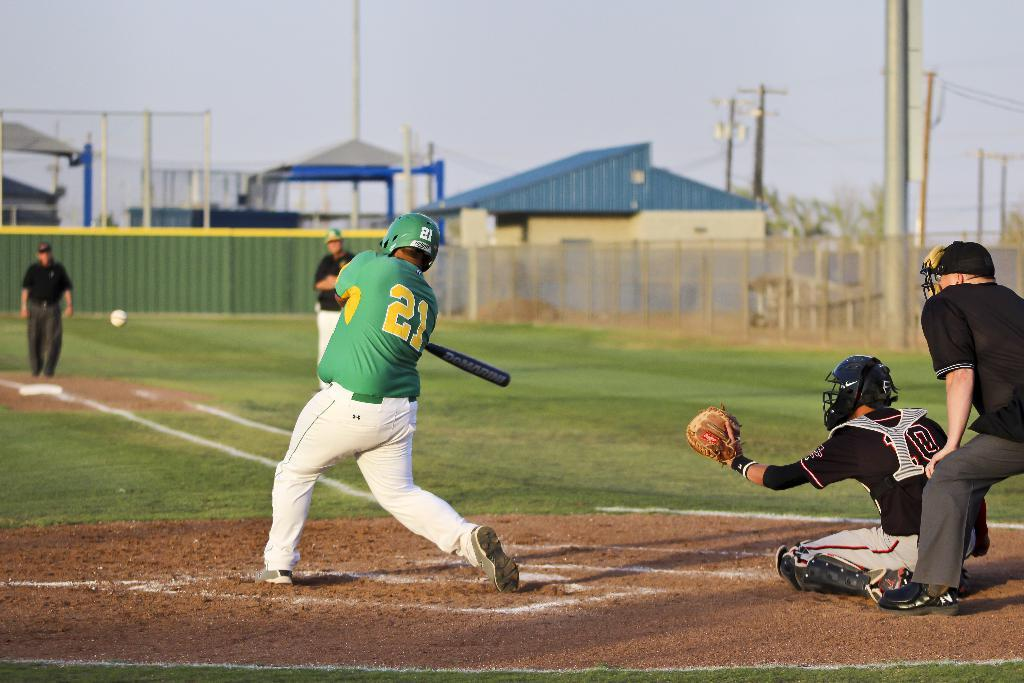<image>
Give a short and clear explanation of the subsequent image. Baseball player in green uniform that has a yellow 21 one the back. 